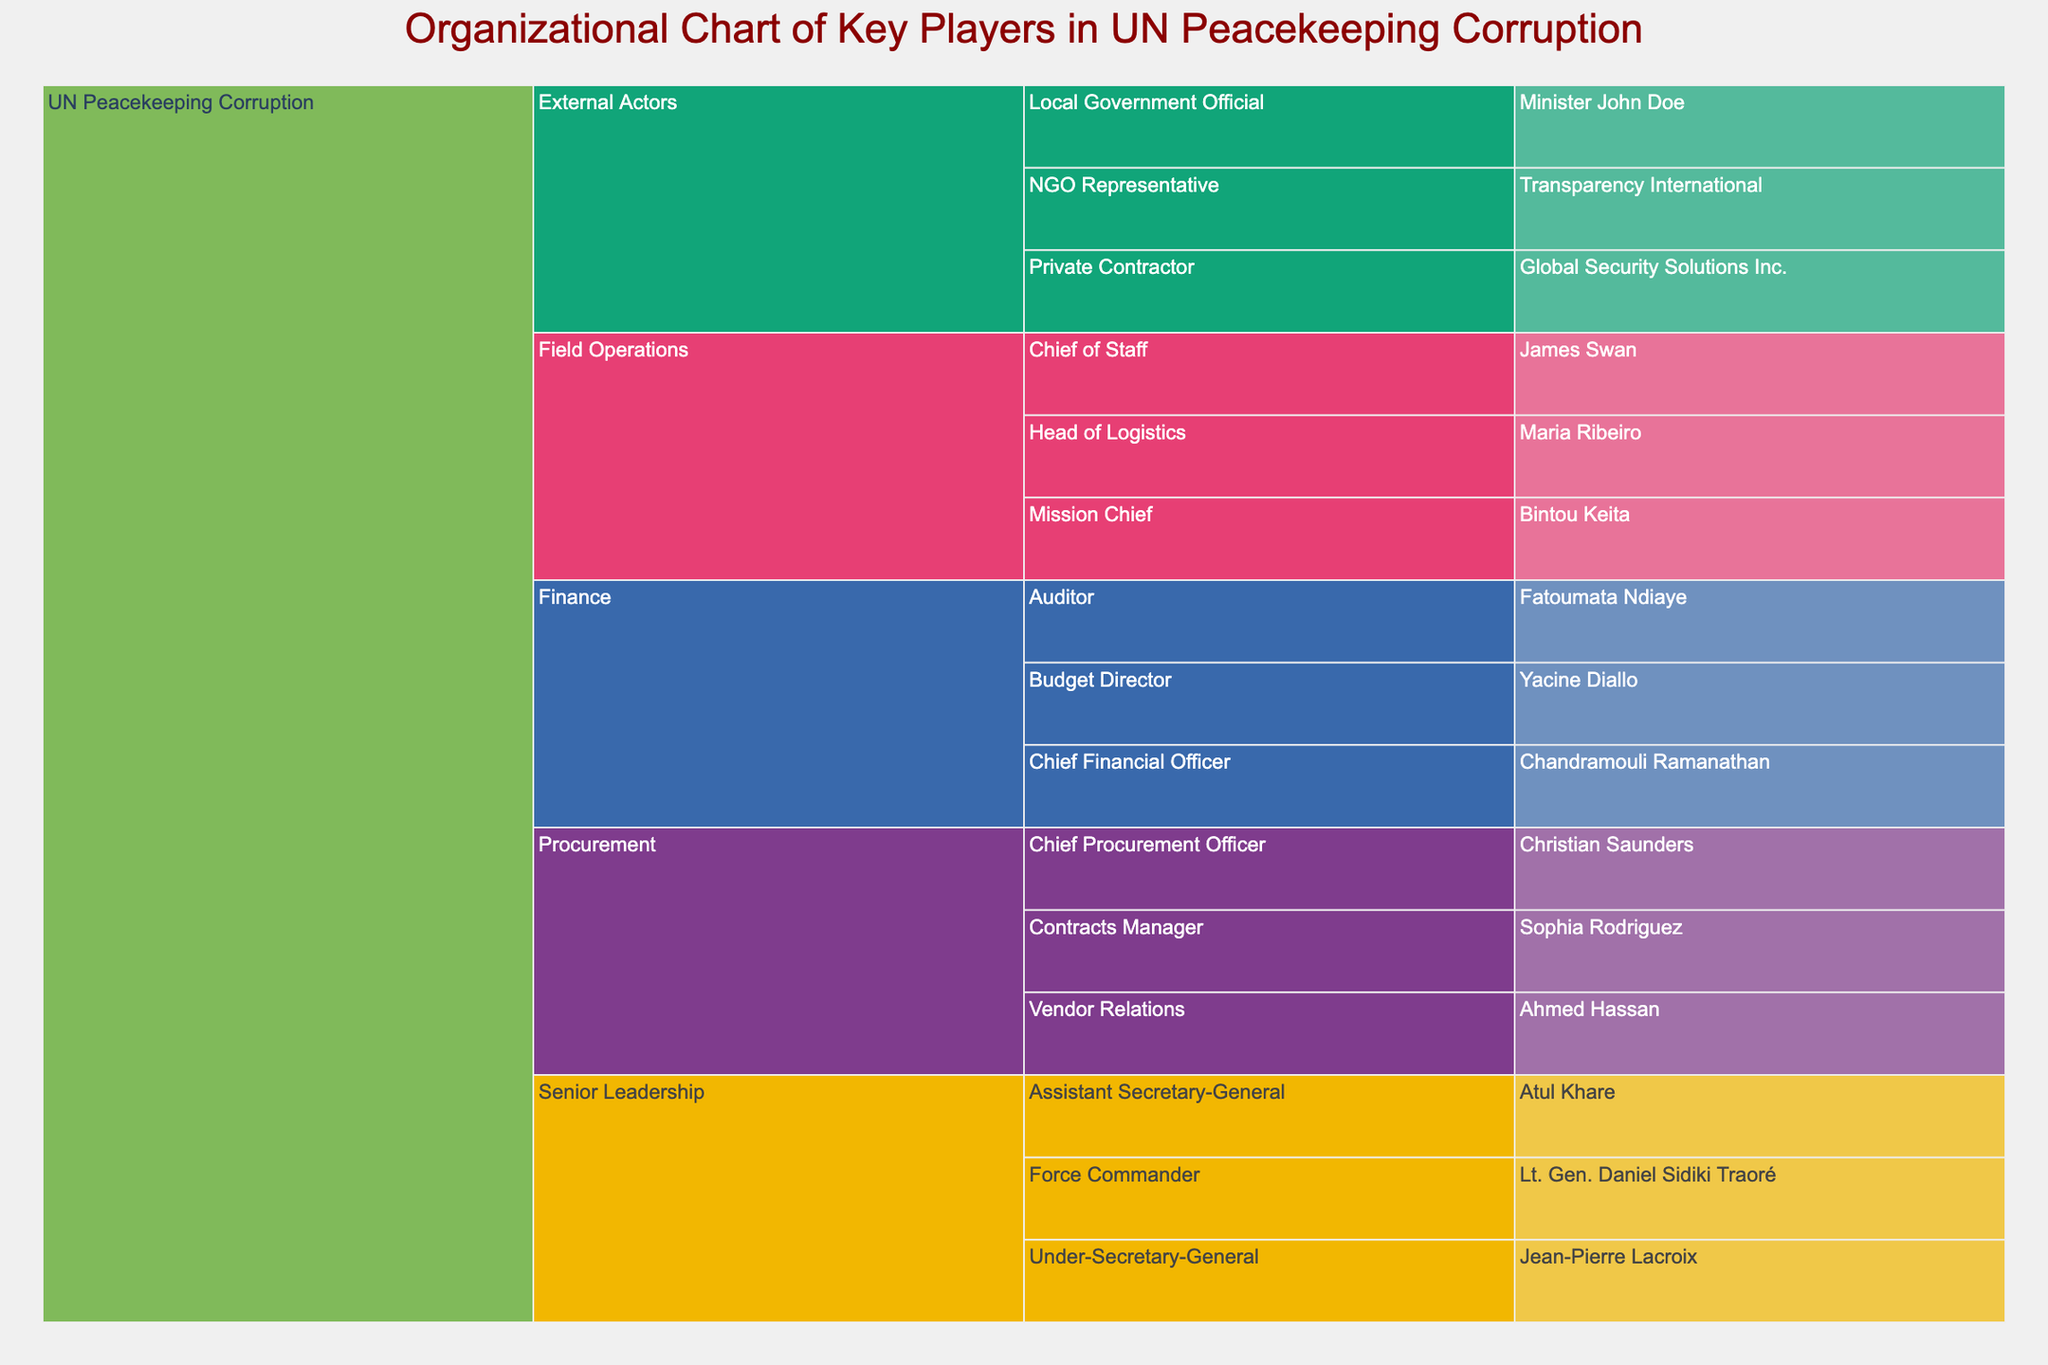what is the title of the chart? The title of the chart is displayed at the top center and clearly labeled. By observing the figure, you can read the title directly from the chart.
Answer: Organizational Chart of Key Players in UN Peacekeeping Corruption How many main categories (Level 1) are there in the chart? The chart uses color to differentiate the main categories at Level 1. You can count the distinct sections directly.
Answer: 5 Which individual holds the role of Chief Financial Officer in the Finance category? By navigating through the Finance category and going down the hierarchy, you can identify the individual assigned the title of Chief Financial Officer.
Answer: Chandramouli Ramanathan How many subcategories are under Field Operations? Within the Field Operations category, there are multiple sub-categories. Counting the branches stemming from Field Operations will give the number of subcategories.
Answer: 3 Who is the Force Commander in the UN Peacekeeping Corruption hierarchy? To find the Force Commander, follow the branch from the root down through the Senior Leadership category.
Answer: Lt. Gen. Daniel Sidiki Traoré Compare the number of roles listed under Procurement and Finance. Which category has more roles? Navigate through both Procurement and Finance categories and count the roles listed under each. Comparing the counts gives the answer.
Answer: Finance has more roles What organization is listed under External Actors as an NGO Representative? Move through the External Actors category and find the NGO Representative subcategory, then identify the corresponding organization listed.
Answer: Transparency International How many individuals are identified in the External Actors category? Within External Actors, count the number of individuals listed excluding organizations. This involves careful counting of each name.
Answer: 1 Which subcategory under Procurement involves dealing with vendors? Check each subcategory under Procurement to identify which one specifically mentions vendor relationships.
Answer: Vendor Relations What is the relationship between Ahmed Hassan and Christian Saunders? Follow the Procurement category to both names and understand their positions within the hierarchy. Ahmed Hassan is under Vendor Relations while Christian Saunders is the Chief Procurement Officer, indicating an organizational relationship.
Answer: Ahmed Hassan is under Christian Saunders in Procurement 